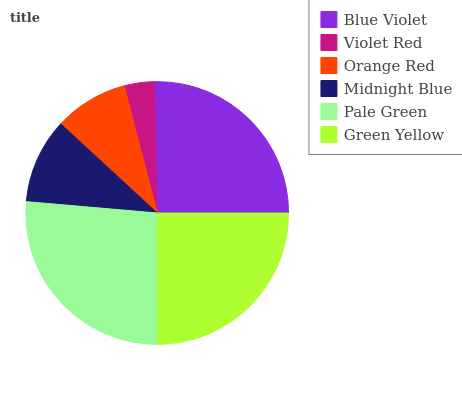Is Violet Red the minimum?
Answer yes or no. Yes. Is Pale Green the maximum?
Answer yes or no. Yes. Is Orange Red the minimum?
Answer yes or no. No. Is Orange Red the maximum?
Answer yes or no. No. Is Orange Red greater than Violet Red?
Answer yes or no. Yes. Is Violet Red less than Orange Red?
Answer yes or no. Yes. Is Violet Red greater than Orange Red?
Answer yes or no. No. Is Orange Red less than Violet Red?
Answer yes or no. No. Is Green Yellow the high median?
Answer yes or no. Yes. Is Midnight Blue the low median?
Answer yes or no. Yes. Is Pale Green the high median?
Answer yes or no. No. Is Pale Green the low median?
Answer yes or no. No. 